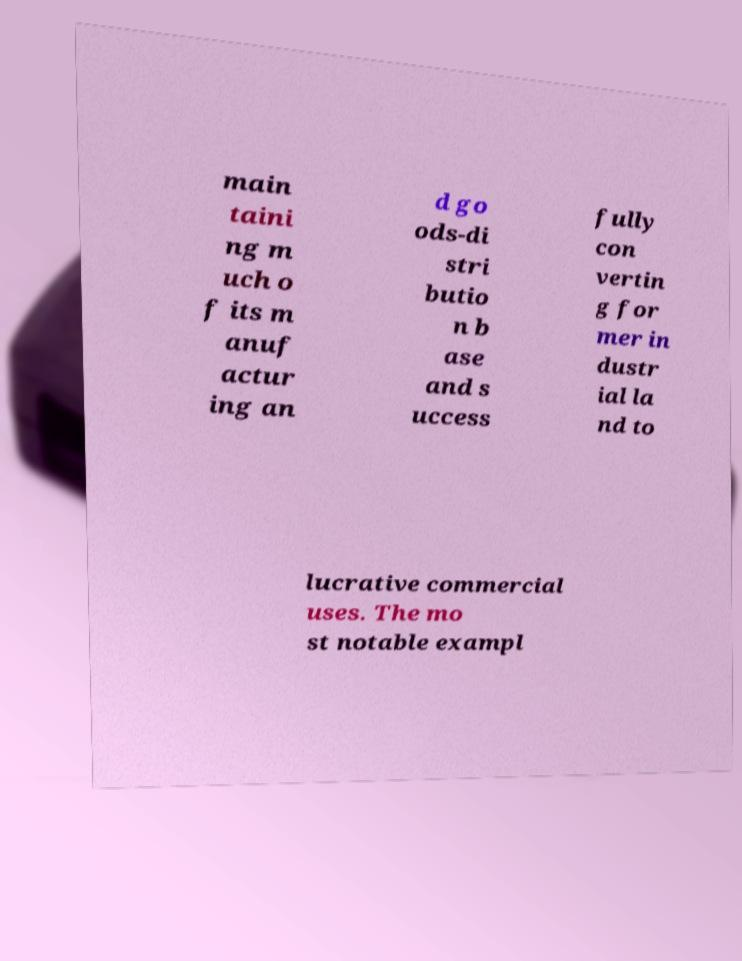Can you accurately transcribe the text from the provided image for me? main taini ng m uch o f its m anuf actur ing an d go ods-di stri butio n b ase and s uccess fully con vertin g for mer in dustr ial la nd to lucrative commercial uses. The mo st notable exampl 